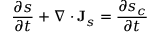<formula> <loc_0><loc_0><loc_500><loc_500>{ \frac { \partial s } { \partial t } } + \nabla \cdot J _ { s } = { \frac { \partial s _ { c } } { \partial t } }</formula> 